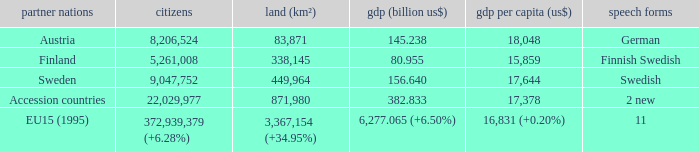Name the member countries for finnish swedish Finland. 